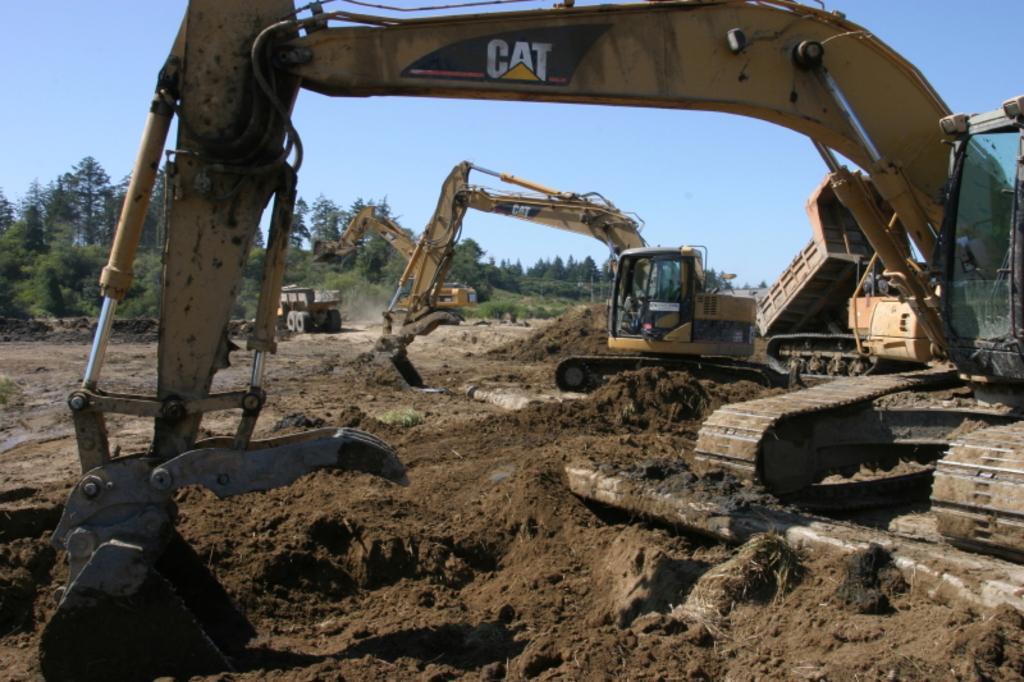Can you describe this image briefly? To the right side of the image there is a proclainer on the ground. In the background there are two proclainer and also there is a truck. And also in the background there are many trees and also there is a sky. 